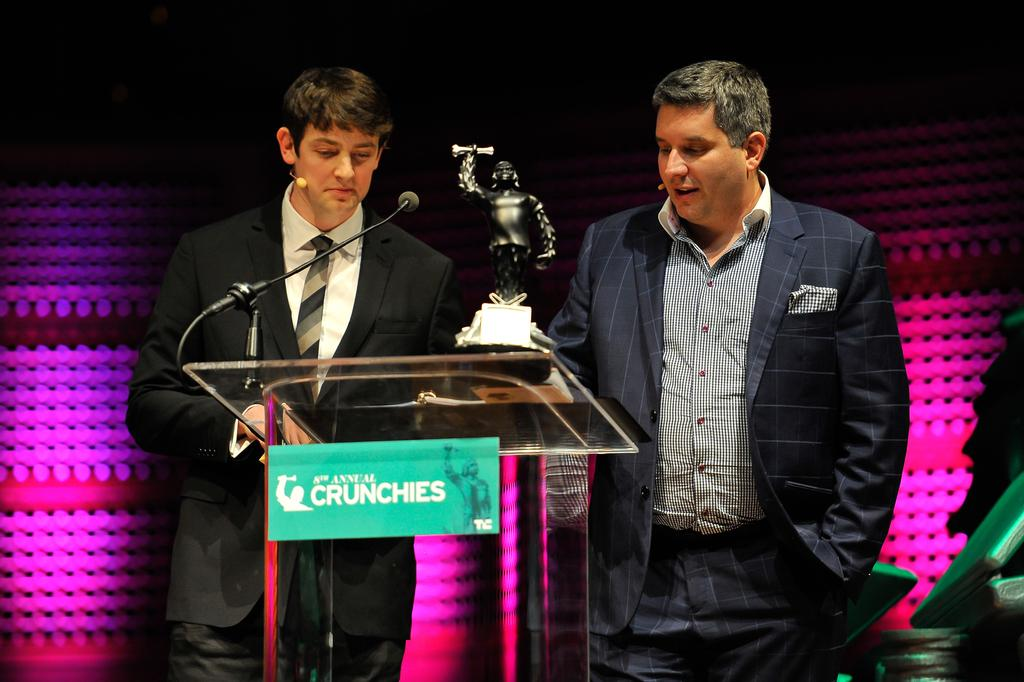How many men are present in the image? There are two men in the image. What are the men wearing on their upper bodies? The men are wearing blazers in the image. What are the men doing in the image? The men are standing at a podium in the image. What object can be seen in the image that might be awarded to someone? There is a trophy in the image. What devices are present in the image for amplifying sound? There are microphones in the image. What type of neckwear are the men wearing? The men are wearing ties in the image. What type of lighting is present in the image? There are lights in the image. What can be said about the background of the image? The background of the image is dark. What type of doll is sitting on the podium next to the men? There is no doll present in the image; only the two men, a trophy, and microphones are visible. 